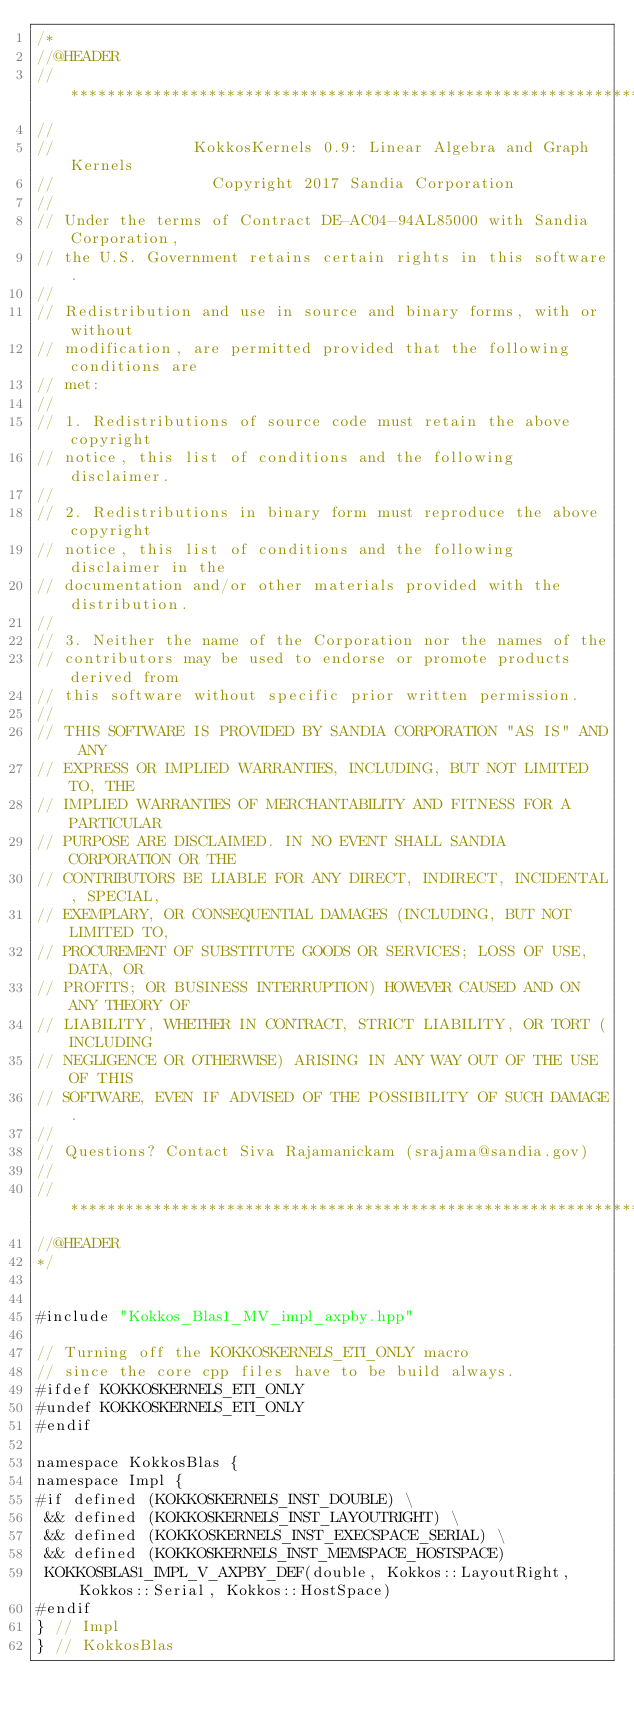<code> <loc_0><loc_0><loc_500><loc_500><_C++_>/*
//@HEADER
// ************************************************************************
//
//               KokkosKernels 0.9: Linear Algebra and Graph Kernels
//                 Copyright 2017 Sandia Corporation
//
// Under the terms of Contract DE-AC04-94AL85000 with Sandia Corporation,
// the U.S. Government retains certain rights in this software.
//
// Redistribution and use in source and binary forms, with or without
// modification, are permitted provided that the following conditions are
// met:
//
// 1. Redistributions of source code must retain the above copyright
// notice, this list of conditions and the following disclaimer.
//
// 2. Redistributions in binary form must reproduce the above copyright
// notice, this list of conditions and the following disclaimer in the
// documentation and/or other materials provided with the distribution.
//
// 3. Neither the name of the Corporation nor the names of the
// contributors may be used to endorse or promote products derived from
// this software without specific prior written permission.
//
// THIS SOFTWARE IS PROVIDED BY SANDIA CORPORATION "AS IS" AND ANY
// EXPRESS OR IMPLIED WARRANTIES, INCLUDING, BUT NOT LIMITED TO, THE
// IMPLIED WARRANTIES OF MERCHANTABILITY AND FITNESS FOR A PARTICULAR
// PURPOSE ARE DISCLAIMED. IN NO EVENT SHALL SANDIA CORPORATION OR THE
// CONTRIBUTORS BE LIABLE FOR ANY DIRECT, INDIRECT, INCIDENTAL, SPECIAL,
// EXEMPLARY, OR CONSEQUENTIAL DAMAGES (INCLUDING, BUT NOT LIMITED TO,
// PROCUREMENT OF SUBSTITUTE GOODS OR SERVICES; LOSS OF USE, DATA, OR
// PROFITS; OR BUSINESS INTERRUPTION) HOWEVER CAUSED AND ON ANY THEORY OF
// LIABILITY, WHETHER IN CONTRACT, STRICT LIABILITY, OR TORT (INCLUDING
// NEGLIGENCE OR OTHERWISE) ARISING IN ANY WAY OUT OF THE USE OF THIS
// SOFTWARE, EVEN IF ADVISED OF THE POSSIBILITY OF SUCH DAMAGE.
//
// Questions? Contact Siva Rajamanickam (srajama@sandia.gov)
//
// ************************************************************************
//@HEADER
*/


#include "Kokkos_Blas1_MV_impl_axpby.hpp"

// Turning off the KOKKOSKERNELS_ETI_ONLY macro
// since the core cpp files have to be build always.
#ifdef KOKKOSKERNELS_ETI_ONLY
#undef KOKKOSKERNELS_ETI_ONLY
#endif

namespace KokkosBlas {
namespace Impl {
#if defined (KOKKOSKERNELS_INST_DOUBLE) \
 && defined (KOKKOSKERNELS_INST_LAYOUTRIGHT) \
 && defined (KOKKOSKERNELS_INST_EXECSPACE_SERIAL) \
 && defined (KOKKOSKERNELS_INST_MEMSPACE_HOSTSPACE)
 KOKKOSBLAS1_IMPL_V_AXPBY_DEF(double, Kokkos::LayoutRight, Kokkos::Serial, Kokkos::HostSpace)
#endif
} // Impl
} // KokkosBlas
</code> 